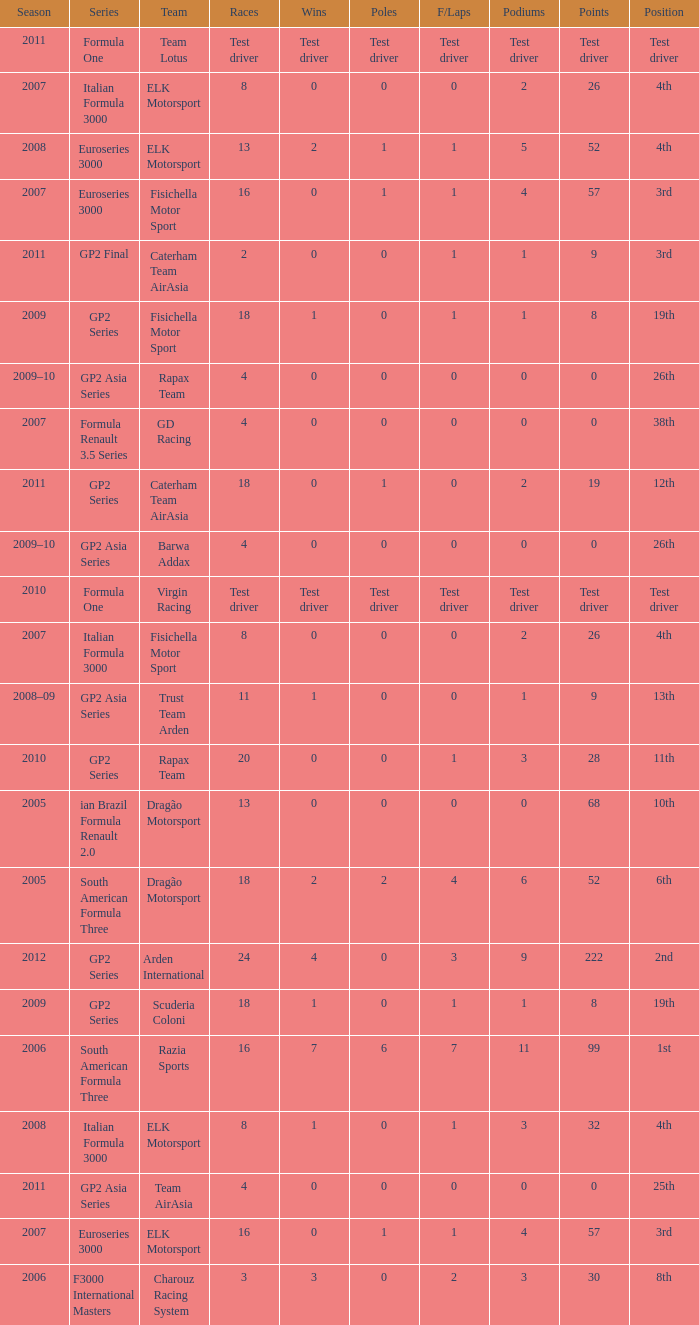How many races did he do in the year he had 8 points? 18, 18. 